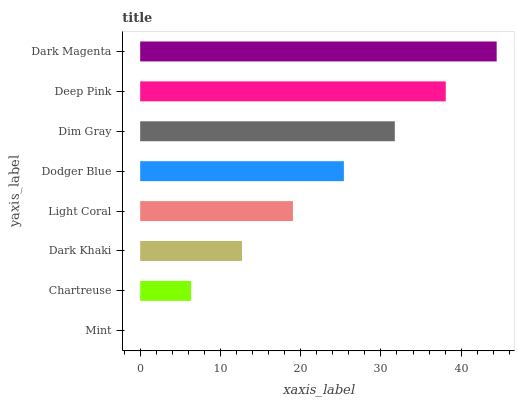Is Mint the minimum?
Answer yes or no. Yes. Is Dark Magenta the maximum?
Answer yes or no. Yes. Is Chartreuse the minimum?
Answer yes or no. No. Is Chartreuse the maximum?
Answer yes or no. No. Is Chartreuse greater than Mint?
Answer yes or no. Yes. Is Mint less than Chartreuse?
Answer yes or no. Yes. Is Mint greater than Chartreuse?
Answer yes or no. No. Is Chartreuse less than Mint?
Answer yes or no. No. Is Dodger Blue the high median?
Answer yes or no. Yes. Is Light Coral the low median?
Answer yes or no. Yes. Is Chartreuse the high median?
Answer yes or no. No. Is Chartreuse the low median?
Answer yes or no. No. 